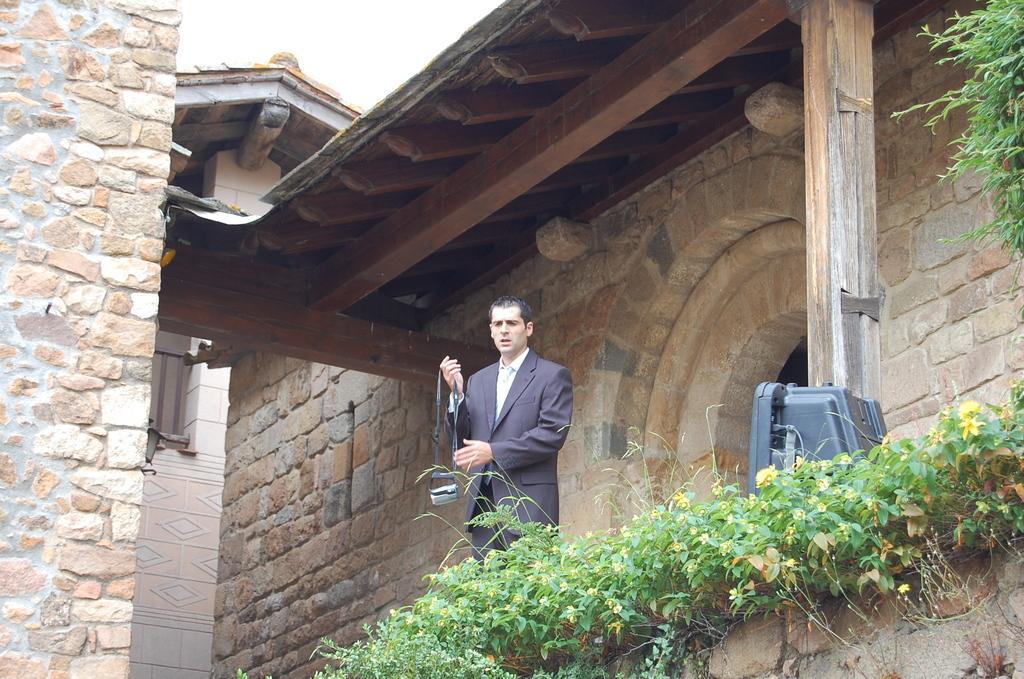Please provide a concise description of this image. In the foreground of the picture there are plants, wall, light and wooden pillar. In the center of the picture there is a person wearing a suit. In the background there are houses and sky. 